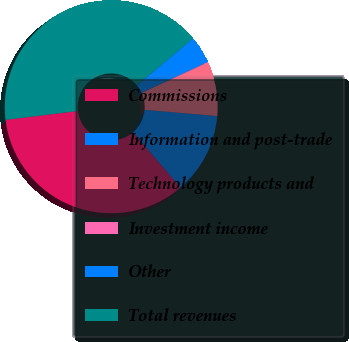Convert chart to OTSL. <chart><loc_0><loc_0><loc_500><loc_500><pie_chart><fcel>Commissions<fcel>Information and post-trade<fcel>Technology products and<fcel>Investment income<fcel>Other<fcel>Total revenues<nl><fcel>34.37%<fcel>12.31%<fcel>8.24%<fcel>0.08%<fcel>4.16%<fcel>40.84%<nl></chart> 